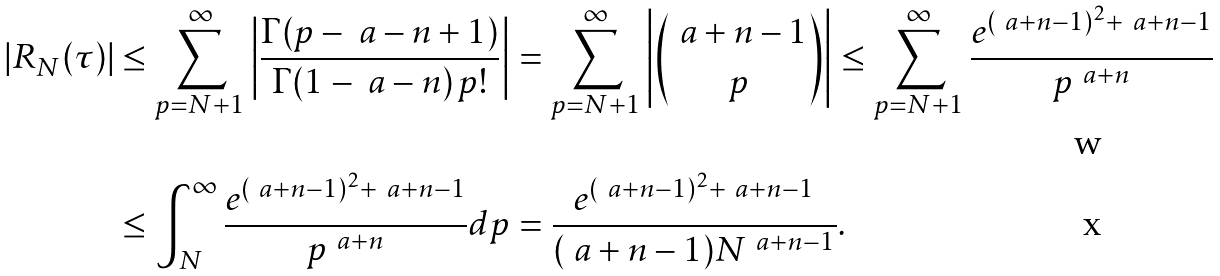Convert formula to latex. <formula><loc_0><loc_0><loc_500><loc_500>\left | R _ { N } ( \tau ) \right | & \leq \sum _ { p = N + 1 } ^ { \infty } \left | \frac { \Gamma ( p - \ a - n + 1 ) } { \Gamma ( 1 - \ a - n ) \, p ! } \right | = \sum _ { p = N + 1 } ^ { \infty } \left | \binom { \ a + n - 1 } { p } \right | \leq \sum _ { p = N + 1 } ^ { \infty } \frac { e ^ { ( \ a + n - 1 ) ^ { 2 } + \ a + n - 1 } } { p ^ { \ a + n } } \\ & \leq \int _ { N } ^ { \infty } \frac { e ^ { ( \ a + n - 1 ) ^ { 2 } + \ a + n - 1 } } { p ^ { \ a + n } } d p = \frac { e ^ { ( \ a + n - 1 ) ^ { 2 } + \ a + n - 1 } } { ( \ a + n - 1 ) N ^ { \ a + n - 1 } } .</formula> 